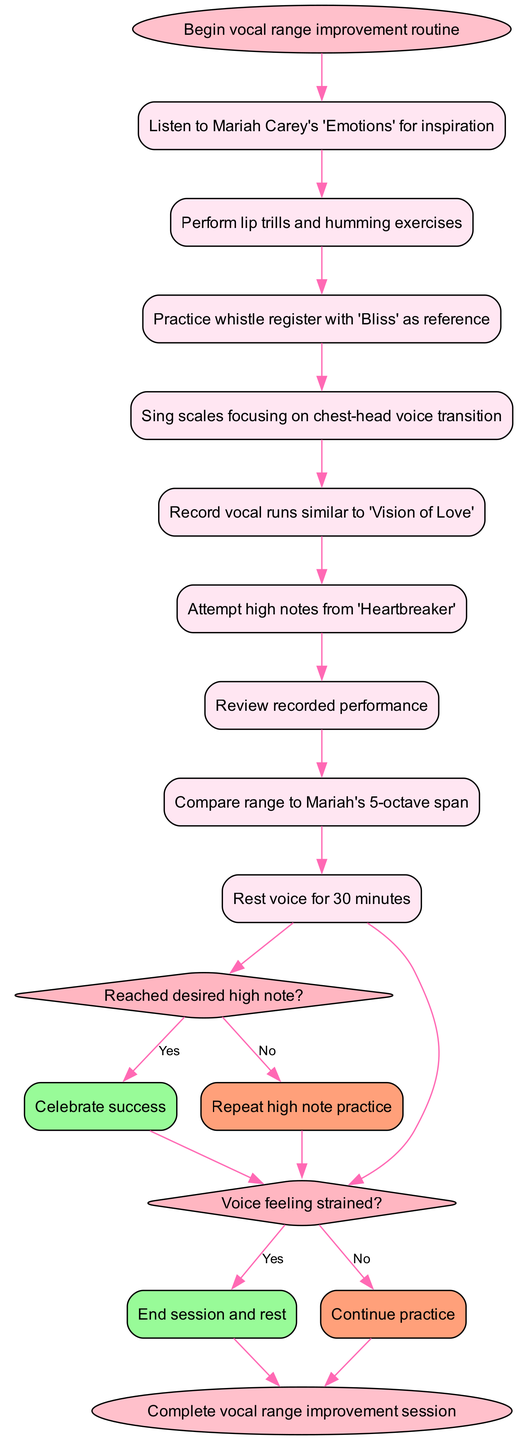What is the first activity in the routine? The first activity listed in the activities section is "Listen to Mariah Carey's 'Emotions' for inspiration." This can be found because it is the very first node following the start node, indicating the first action to take.
Answer: Listen to Mariah Carey's 'Emotions' for inspiration How many activities are included in the diagram? The diagram lists a total of 8 labeled activities from the beginning to the last before the decision nodes. Counting each of them reveals their quantity.
Answer: 8 What is the decision made after "Attempt high notes from 'Heartbreaker'"? After this activity, the decision made is "Reached desired high note?" which leads to two separate outcomes based on the answer to this question, making it a key decision point in the process.
Answer: Reached desired high note? What happens if the voice feels strained? If the voice feels strained, the decision indicated says to "End session and rest." This is a direct outcome of the decision made after the activities, guiding the next actions based on voice condition.
Answer: End session and rest What do you do if you did not reach the desired high note? If the answer to the decision about reaching the desired high note is "No," the next action indicated in the flow is to "Repeat high note practice," suggesting a continued effort to achieve the goal.
Answer: Repeat high note practice How do you evaluate your practice session according to the diagram? The evaluation of the practice session is done by "Review recorded performance," which is a clear step in the activity sequence that encourages self-assessment based on recordings.
Answer: Review recorded performance What is the last step of the routine? The last step indicated in the diagram is "Complete vocal range improvement session," which signifies the end of all activities and decisions made throughout the process.
Answer: Complete vocal range improvement session What do you do after attempting high notes? After attempting high notes, there is a decision to be made about whether the desired high note was reached, which determines the next action of the routine.
Answer: Reach decision on high note What is the consequence of not resting your voice if it feels strained? If the voice feels strained and it is not addressed, it leads to potential continuation of practice, but according to the decision flow, it suggests "End session and rest" accordingly if the condition is neglected.
Answer: End session and rest 